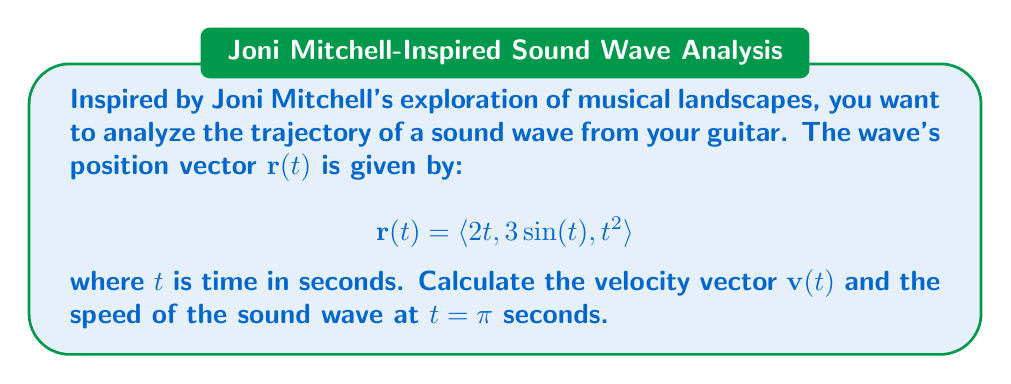Teach me how to tackle this problem. To solve this problem, we'll follow these steps:

1) First, we need to find the velocity vector $\mathbf{v}(t)$. The velocity vector is the derivative of the position vector with respect to time:

   $$\mathbf{v}(t) = \frac{d}{dt}\mathbf{r}(t) = \left\langle \frac{d}{dt}(2t), \frac{d}{dt}(3\sin(t)), \frac{d}{dt}(t^2) \right\rangle$$

2) Let's calculate each component:
   
   - $\frac{d}{dt}(2t) = 2$
   - $\frac{d}{dt}(3\sin(t)) = 3\cos(t)$
   - $\frac{d}{dt}(t^2) = 2t$

3) Therefore, the velocity vector is:

   $$\mathbf{v}(t) = \langle 2, 3\cos(t), 2t \rangle$$

4) Now, we need to find $\mathbf{v}(\pi)$:

   $$\mathbf{v}(\pi) = \langle 2, 3\cos(\pi), 2\pi \rangle = \langle 2, -3, 2\pi \rangle$$

5) To find the speed at $t = \pi$, we need to calculate the magnitude of the velocity vector at $t = \pi$:

   $$\text{speed} = \|\mathbf{v}(\pi)\| = \sqrt{2^2 + (-3)^2 + (2\pi)^2}$$

6) Simplifying:

   $$\text{speed} = \sqrt{4 + 9 + 4\pi^2} = \sqrt{13 + 4\pi^2}$$

This is the speed of the sound wave at $t = \pi$ seconds.
Answer: The velocity vector is $\mathbf{v}(t) = \langle 2, 3\cos(t), 2t \rangle$, and the speed of the sound wave at $t = \pi$ seconds is $\sqrt{13 + 4\pi^2}$ units per second. 